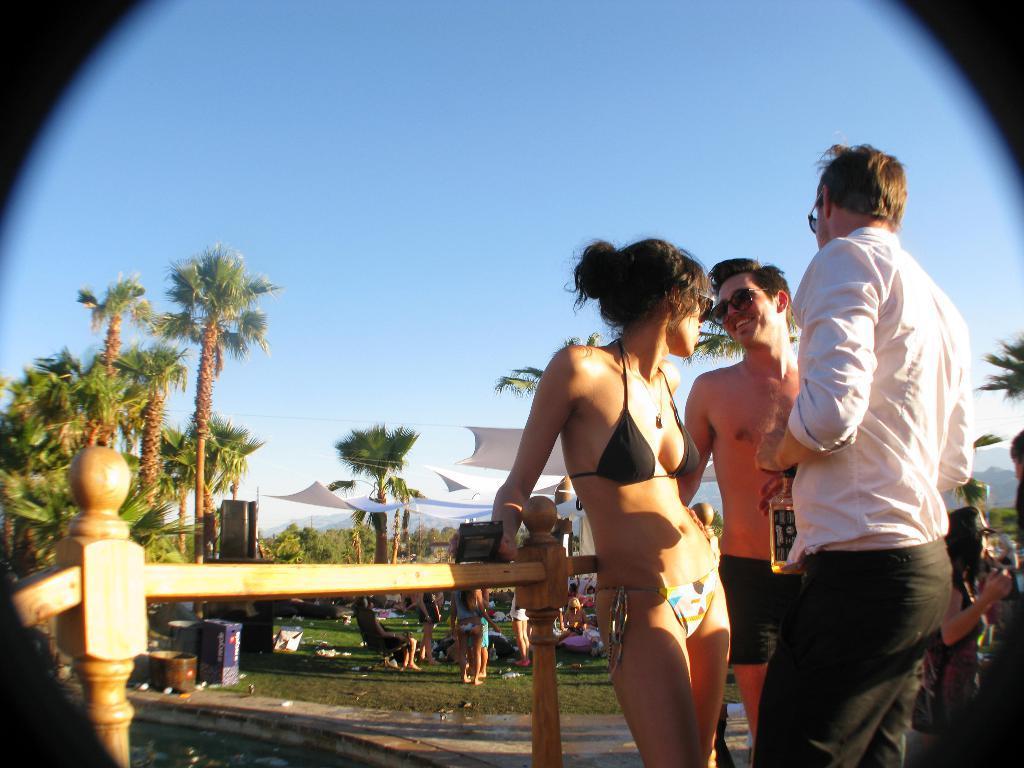Please provide a concise description of this image. In this image I can see few people and one person is holding something. I can see few trees, fencing, white color clothes and few objects. The sky is in blue color. 